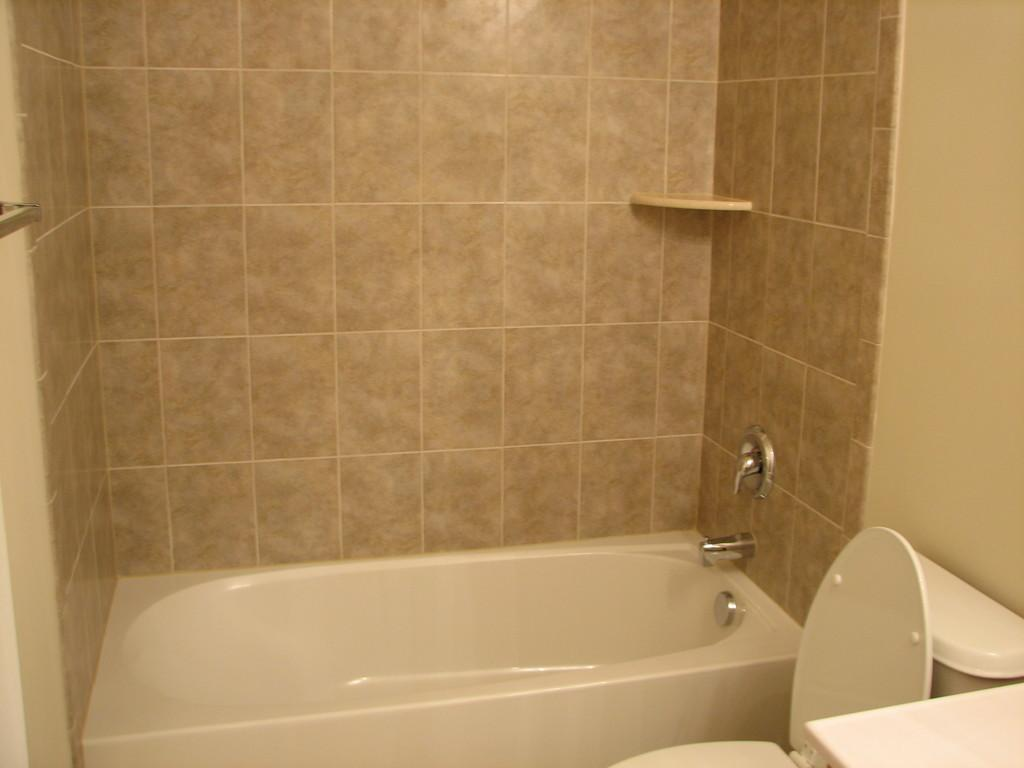What type of bathtub is in the image? There is a white color bathtub in the image. What other fixture is present in the image? There is a western toilet in the image. What can be seen behind the bathtub and toilet? There is a wall visible in the image. What type of glove is being used by the servant in the image? There is no glove or servant present in the image. 